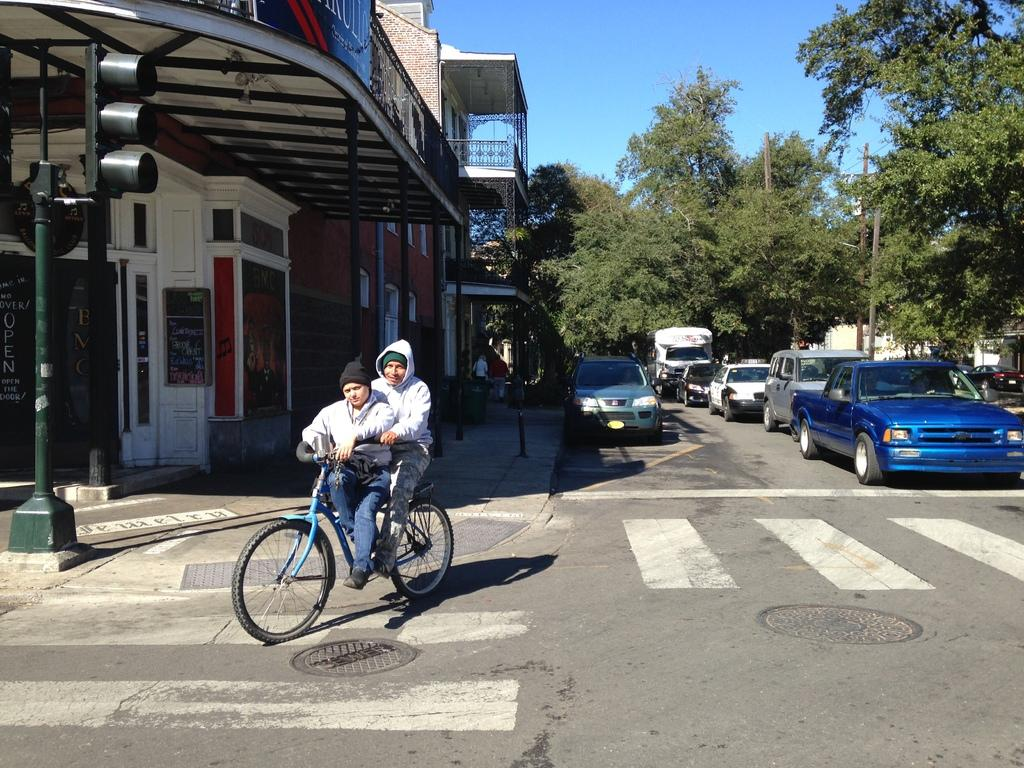What type of structure is present in the image? There is a building in the image. What type of natural elements can be seen in the image? There are trees in the image. What type of vehicles are parked in the image? There are parked cars in the image. What type of transportation are two people using in the image? There are two people moving on a bicycle in the image. How many visitors from a different nation can be seen in the image? There is no reference to visitors or a different nation in the image. Is there a beggar visible in the image? There is no beggar present in the image. 